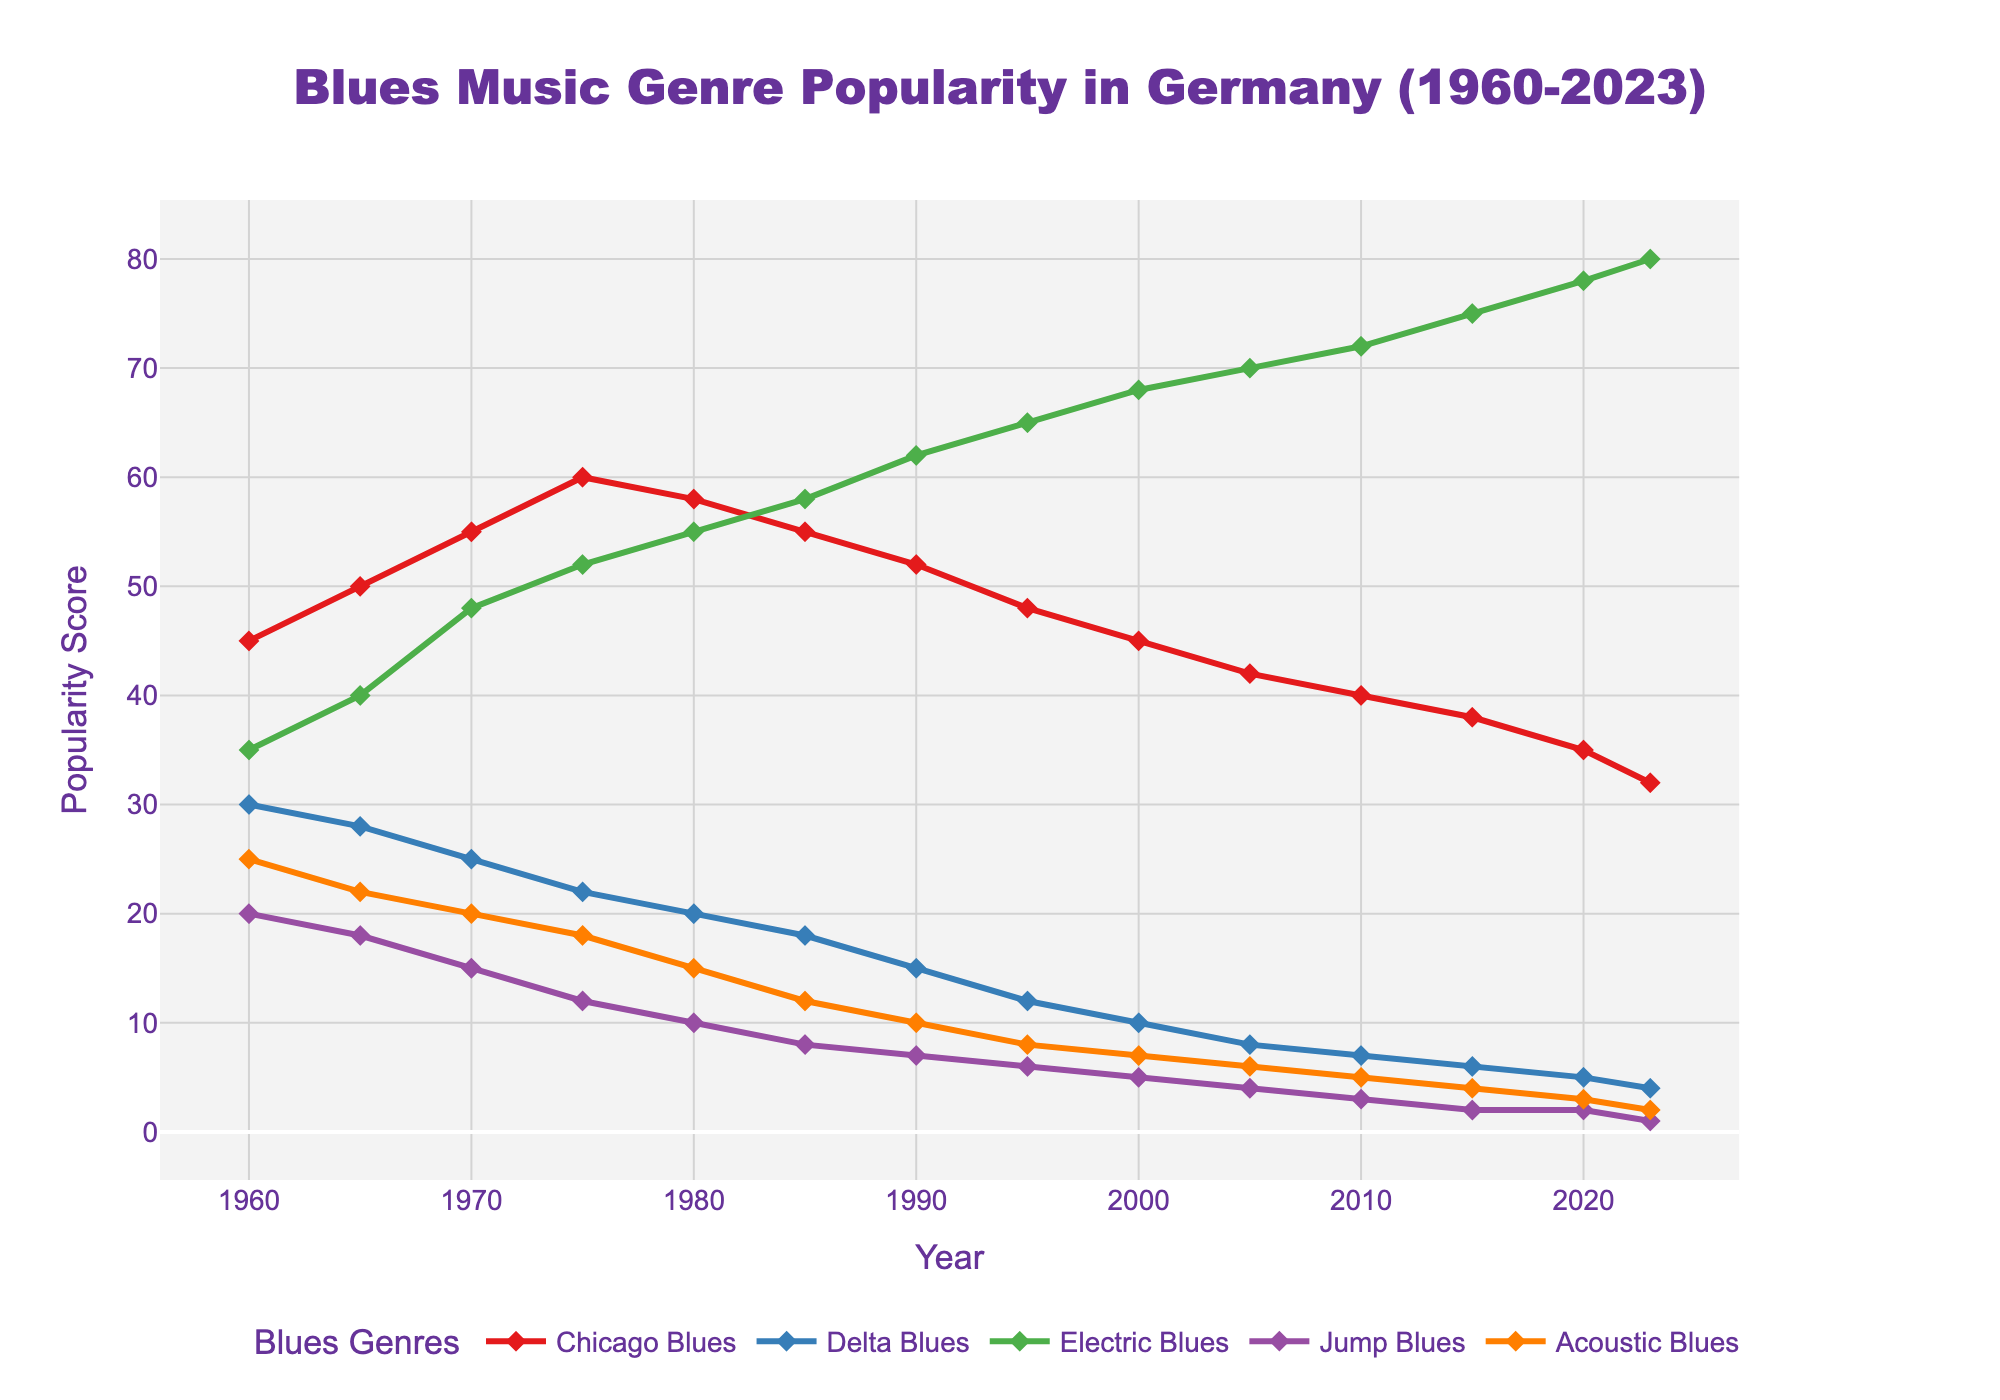what is the difference in popularity between Chicago Blues and Electric Blues in 2023? To find the difference, you subtract the popularity score of Chicago Blues from Electric Blues in 2023. Electric Blues: 80, Chicago Blues: 32. Difference = 80 - 32 = 48
Answer: 48 Which genre showed the most consistent upward trend since 1960? To determine which genre showed the most consistent upward trend, observe each line from 1960 to 2023. Electric Blues shows a clear and steady increase throughout the period.
Answer: Electric Blues What was the popularity of Delta Blues in 1980 compared to Acoustic Blues? Look at the values for Delta Blues and Acoustic Blues in 1980. Delta Blues: 20, Acoustic Blues: 15. Delta Blues had a higher popularity.
Answer: Delta Blues had higher popularity What decade experienced the largest decline in the popularity of Chicago Blues? Check the difference in popularity for Chicago Blues over each decade. The largest decline occurred from 1980 (58) to 1990 (52), which is a decrease of 6 points.
Answer: 1980-1990 In which year did Jump Blues have its lowest popularity score? Find the lowest point on the Jump Blues line. The lowest score is in 2023 with a score of 1.
Answer: 2023 How much did the popularity of Electric Blues increase from 1975 to 1995? Calculate the increase from 1975 (52) to 1995 (65). Increase = 65 - 52 = 13
Answer: 13 What similarities do you observe in the trends of Chicago Blues and Acoustic Blues? Both genres show a generally downward trend from 1960 to 2023, with brief periods of slower decline.
Answer: Both show a downward trend Compare the popularity of all genres in 2010. Which was the most and least popular? Evaluate the scores for each genre in 2010. Chicago Blues: 40, Delta Blues: 7, Electric Blues: 72, Jump Blues: 3, Acoustic Blues: 5. Most popular: Electric Blues (72), Least popular: Jump Blues (3)
Answer: Most popular: Electric Blues, Least popular: Jump Blues What is the average popularity of Delta Blues from 1960 to 2023? Sum up the popularity scores for Delta Blues from 1960 to 2023 and divide by the number of years. (30 + 28 + 25 + 22 + 20 + 18 + 15 + 12 + 10 + 8 + 7 + 6 + 5 + 4) / 14 = 15.
Answer: 15 